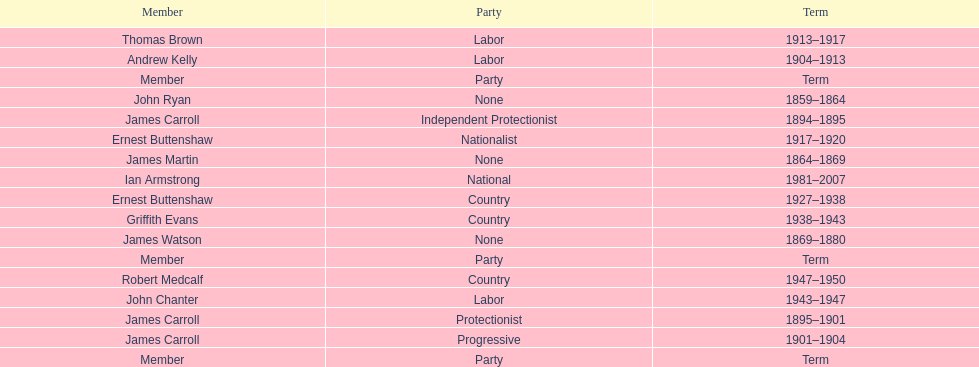Of the members of the third incarnation of the lachlan, who served the longest? Ernest Buttenshaw. 